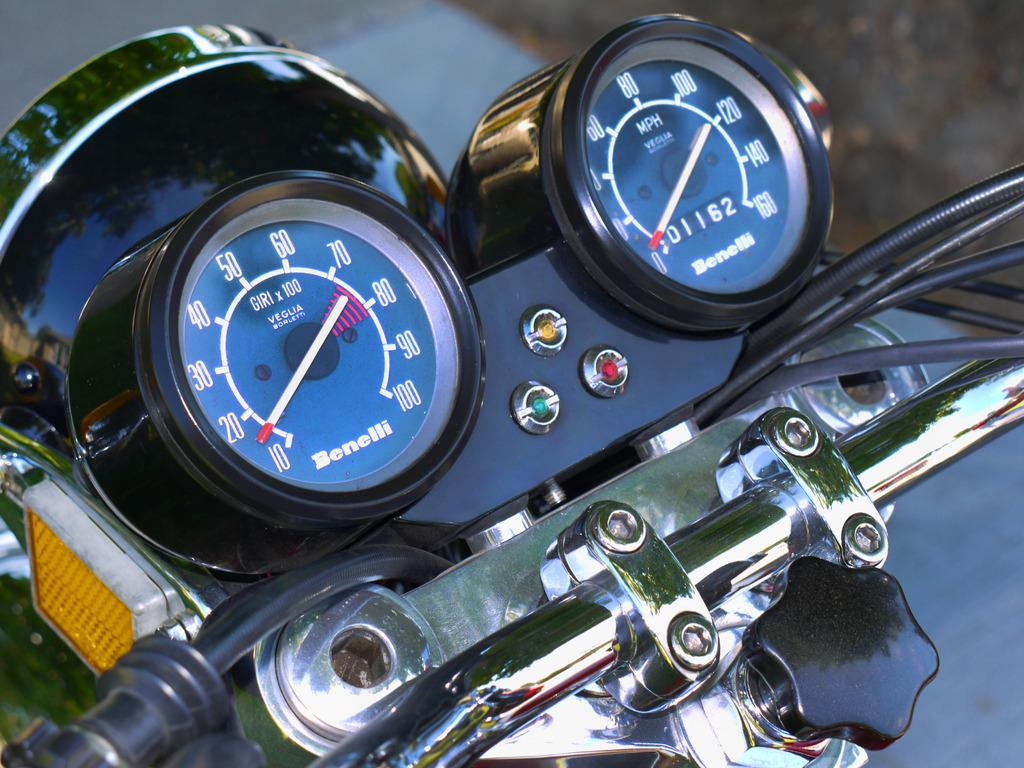What type of vehicle does the speedometer in the image belong to? The speedometer in the image belongs to a bike. What other part of the bike can be seen in the image? There is a handle in the image. What feature is present for illumination in the image? There is a headlight in the image. How many rings are visible on the handle of the bike in the image? There are no rings visible on the handle of the bike in the image. What type of surprise is depicted in the image? There is no surprise depicted in the image; it features a speedometer, handle, and headlight of a bike. Is there a horse present in the image? There is no horse present in the image. 